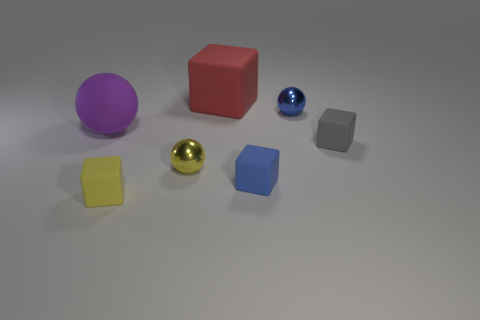Is the matte ball the same color as the large rubber cube?
Your answer should be compact. No. There is a shiny ball that is in front of the blue shiny thing; is it the same size as the rubber thing behind the purple rubber ball?
Your answer should be compact. No. The small object that is behind the tiny matte cube that is to the right of the blue object that is behind the purple rubber thing is what color?
Your answer should be compact. Blue. Is there a large object that has the same shape as the small yellow metal thing?
Offer a terse response. Yes. Is the number of matte blocks behind the blue metallic thing greater than the number of yellow matte spheres?
Provide a short and direct response. Yes. How many rubber things are large cubes or small gray cubes?
Your answer should be very brief. 2. How big is the thing that is both on the left side of the small blue shiny ball and behind the purple thing?
Offer a terse response. Large. Are there any tiny spheres that are behind the large rubber thing that is to the left of the large red cube?
Your response must be concise. Yes. How many small balls are on the left side of the yellow rubber block?
Provide a succinct answer. 0. There is a big rubber thing that is the same shape as the small blue rubber thing; what is its color?
Give a very brief answer. Red. 